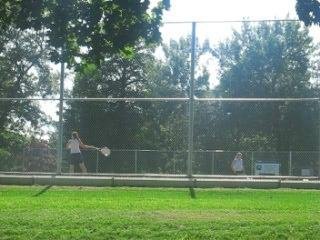What would this fence help to contain? Please explain your reasoning. balls. The fence is up so nothing will go flying outside of it while they are playing tennis. 